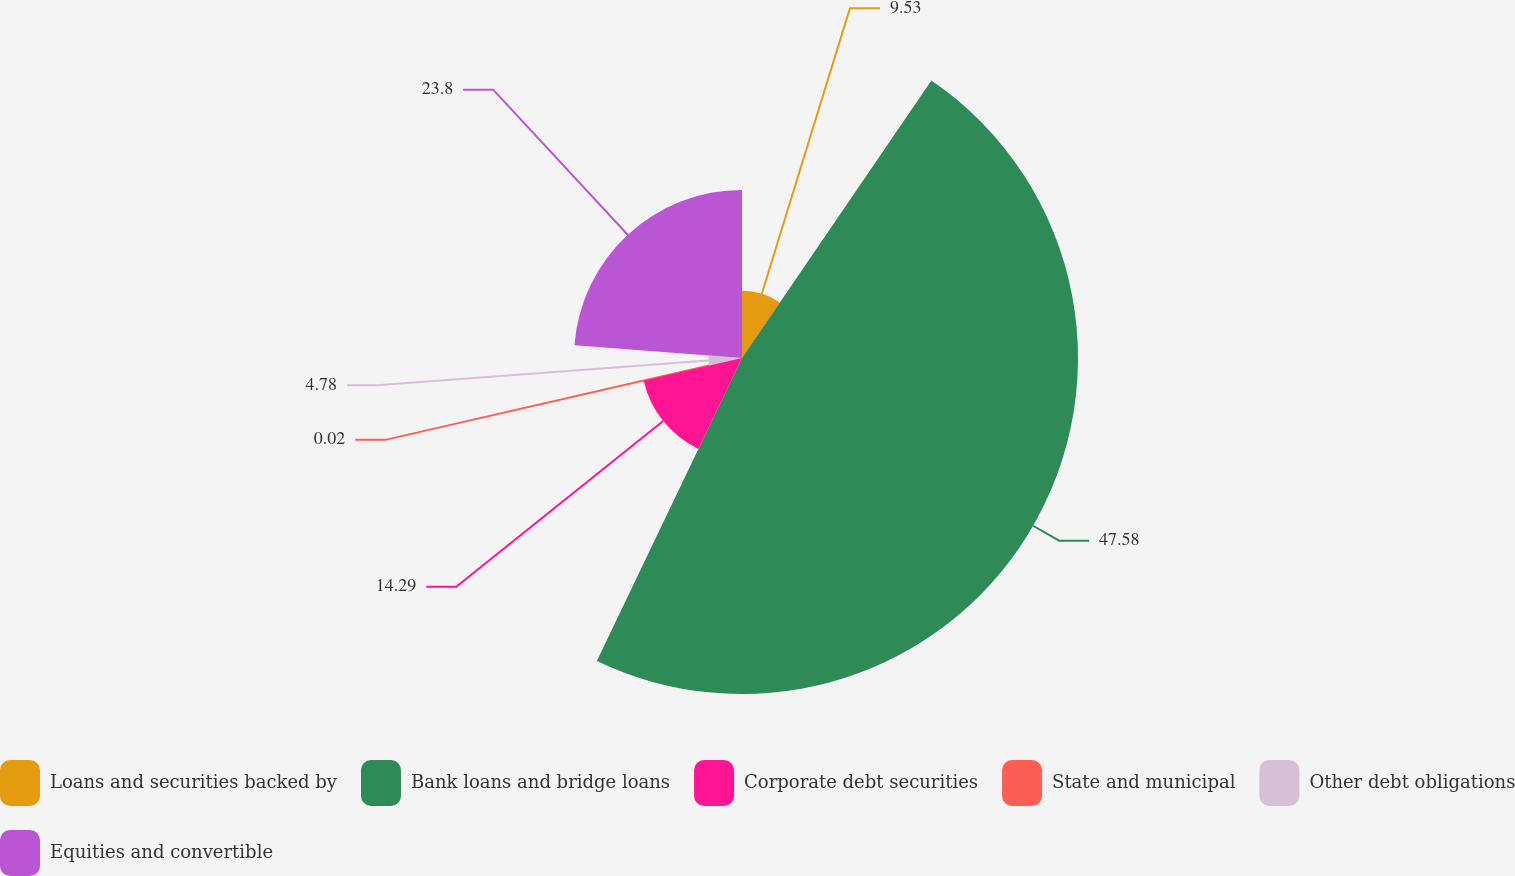Convert chart. <chart><loc_0><loc_0><loc_500><loc_500><pie_chart><fcel>Loans and securities backed by<fcel>Bank loans and bridge loans<fcel>Corporate debt securities<fcel>State and municipal<fcel>Other debt obligations<fcel>Equities and convertible<nl><fcel>9.53%<fcel>47.58%<fcel>14.29%<fcel>0.02%<fcel>4.78%<fcel>23.8%<nl></chart> 